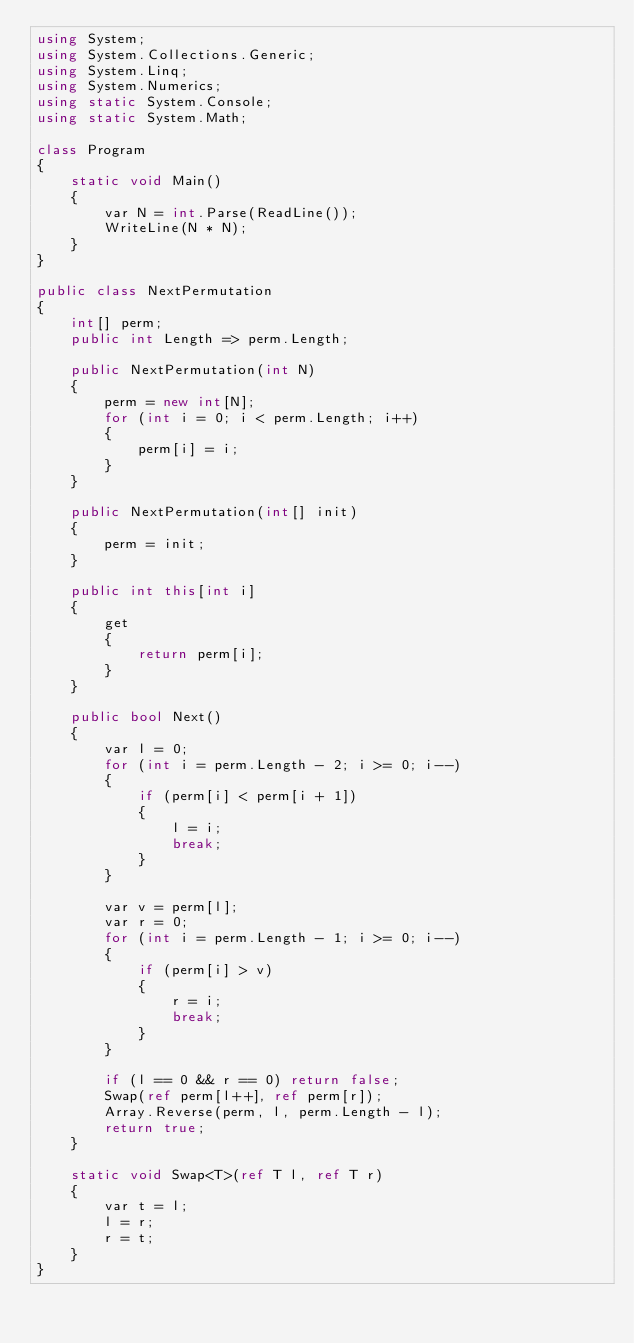<code> <loc_0><loc_0><loc_500><loc_500><_C#_>using System;
using System.Collections.Generic;
using System.Linq;
using System.Numerics;
using static System.Console;
using static System.Math;

class Program
{
    static void Main()
    {
        var N = int.Parse(ReadLine());
        WriteLine(N * N);
    }
}

public class NextPermutation
{
    int[] perm;
    public int Length => perm.Length;

    public NextPermutation(int N)
    {
        perm = new int[N];
        for (int i = 0; i < perm.Length; i++)
        {
            perm[i] = i;
        }
    }

    public NextPermutation(int[] init)
    {
        perm = init;
    }

    public int this[int i]
    {
        get
        {
            return perm[i];
        }
    }

    public bool Next()
    {
        var l = 0;
        for (int i = perm.Length - 2; i >= 0; i--)
        {
            if (perm[i] < perm[i + 1])
            {
                l = i;
                break;
            }
        }

        var v = perm[l];
        var r = 0;
        for (int i = perm.Length - 1; i >= 0; i--)
        {
            if (perm[i] > v)
            {
                r = i;
                break;
            }
        }

        if (l == 0 && r == 0) return false;
        Swap(ref perm[l++], ref perm[r]);
        Array.Reverse(perm, l, perm.Length - l);
        return true;
    }

    static void Swap<T>(ref T l, ref T r)
    {
        var t = l;
        l = r;
        r = t;
    }
}</code> 